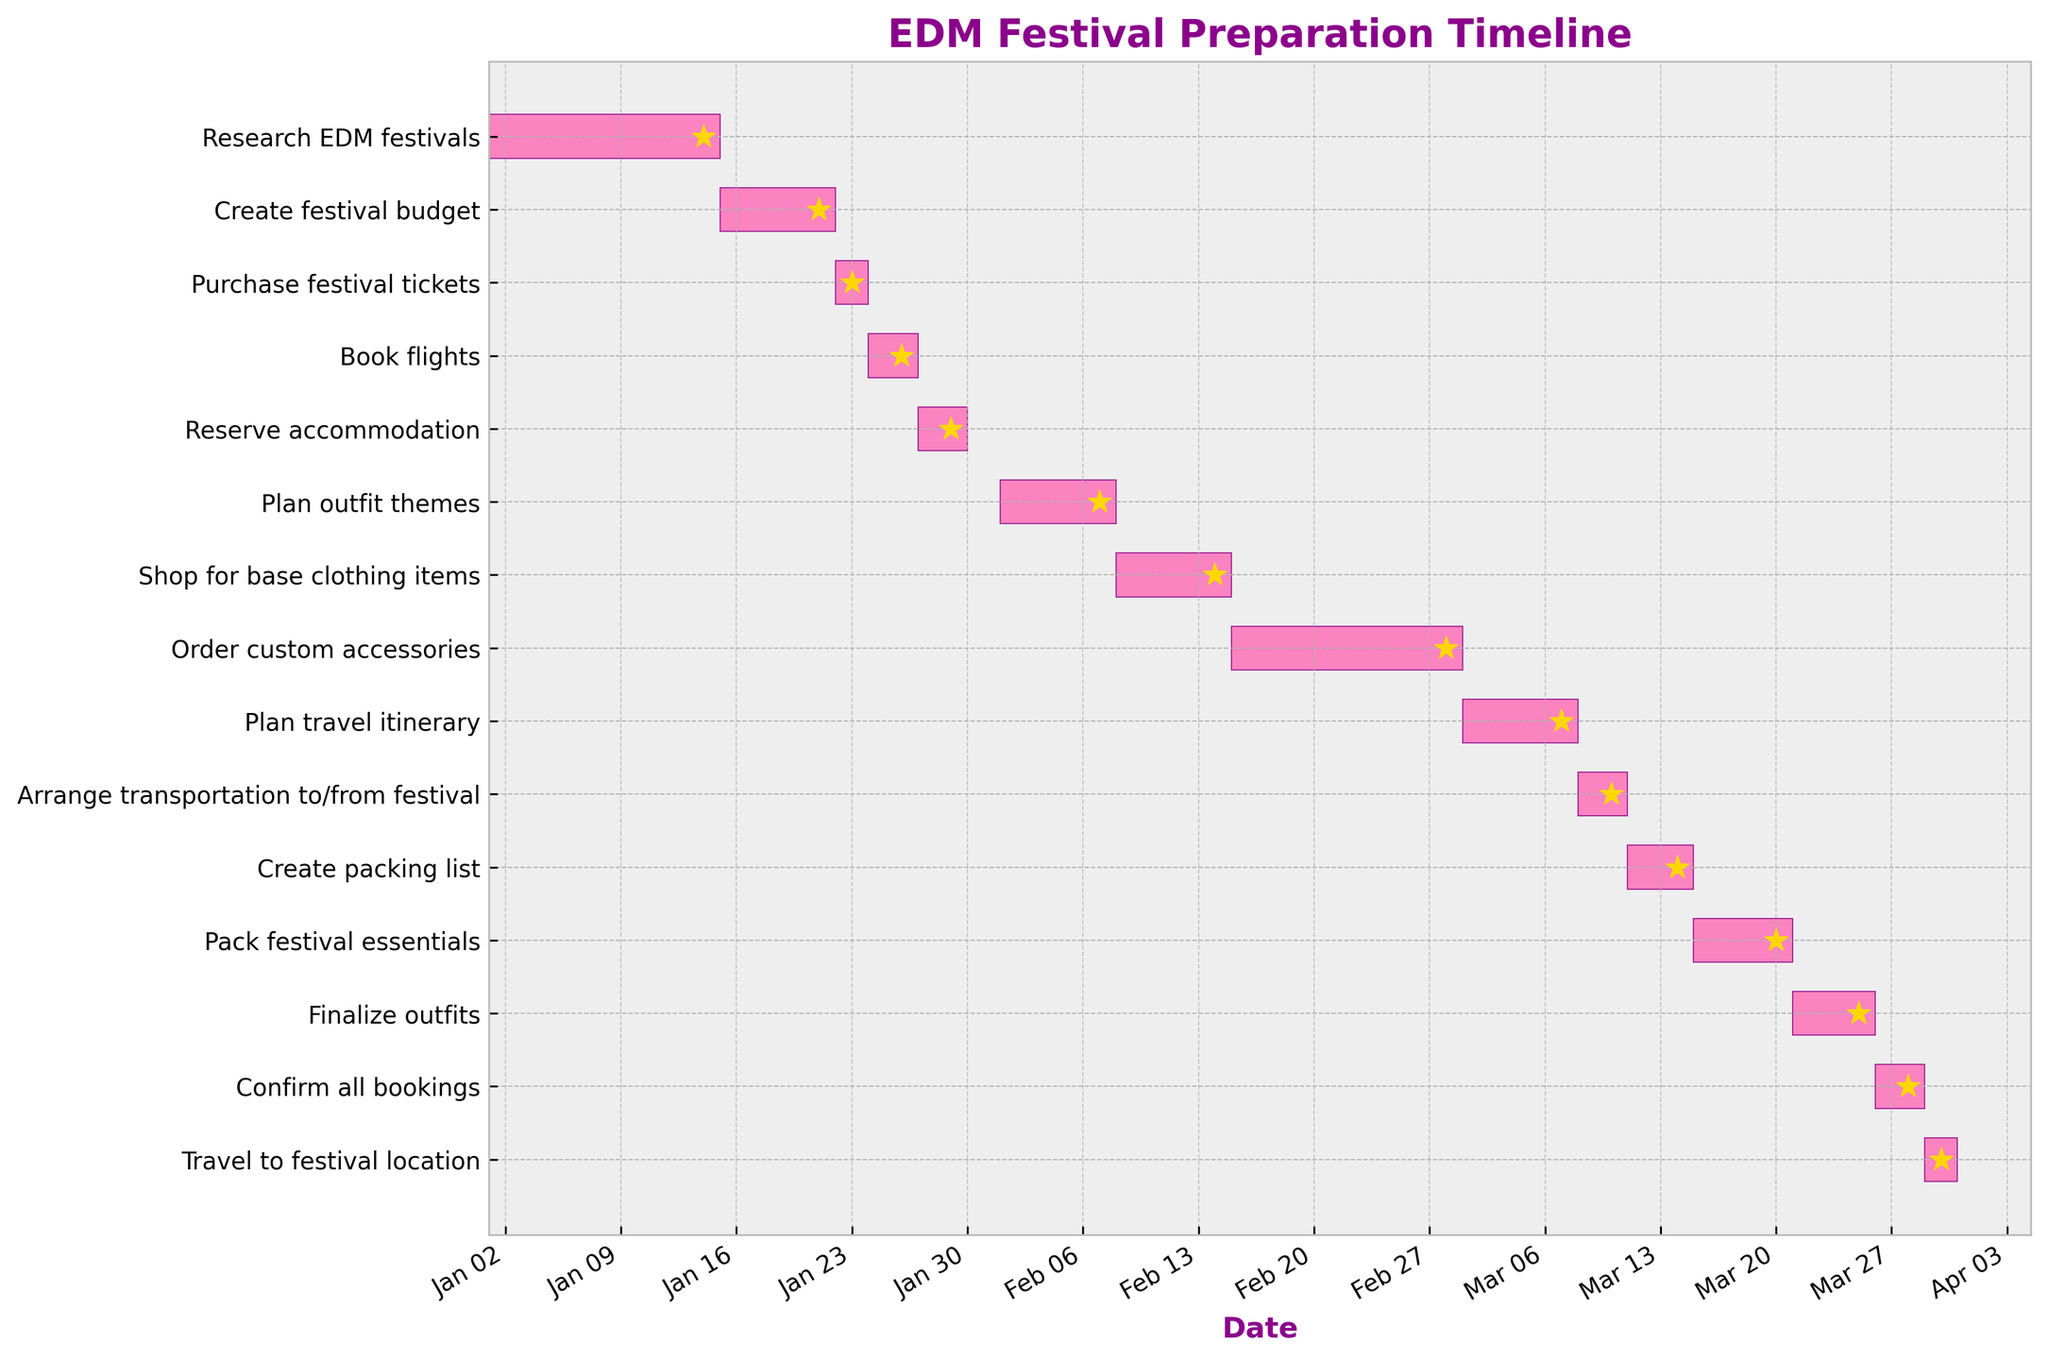what is the title of the Gantt chart? The title is usually located at the top of the chart and summarizes the main purpose of the chart. In this case, it should describe the overall goal of the timeline.
Answer: EDM Festival Preparation Timeline how many tasks are included in the preparation timeline? Count the number of horizontal bars present in the chart, each corresponding to a different task.
Answer: 15 which task has the longest duration? Compare the lengths of the horizontal bars to determine which one spans the most days.
Answer: Order custom accessories during which dates is the 'Book flights' task scheduled? Locate the 'Book flights' task on the y-axis and refer to the start and end points on the x-axis to get the specific dates.
Answer: Jan 24 to Jan 26 which tasks are scheduled for February? Examine the x-axis for the month of February and note which tasks' horizontal bars intersect this section.
Answer: Plan outfit themes, Shop for base clothing items, Order custom accessories how many days was spent on planning the travel itinerary? Find the 'Plan travel itinerary' task and count the days between the start and end dates.
Answer: 7 days how long is the gap between purchasing festival tickets and booking flights? Note the end date of 'Purchase festival tickets' and the start date of 'Book flights', then count the days in between to get the gap duration.
Answer: 1 day which task is completed right before 'confirm all bookings'? Look for the task listed immediately above 'confirm all bookings' in the chart's chronological order.
Answer: Finalize outfits which month has the highest number of tasks scheduled? Count the number of tasks scheduled in each month by examining where the horizontal bars fall in the timeline.
Answer: March which tasks are related to outfit preparation? Identify tasks that mention outfit selection, accessories, or related activities by their descriptions and locations on the y-axis.
Answer: Plan outfit themes, Shop for base clothing items, Order custom accessories, Finalize outfits 